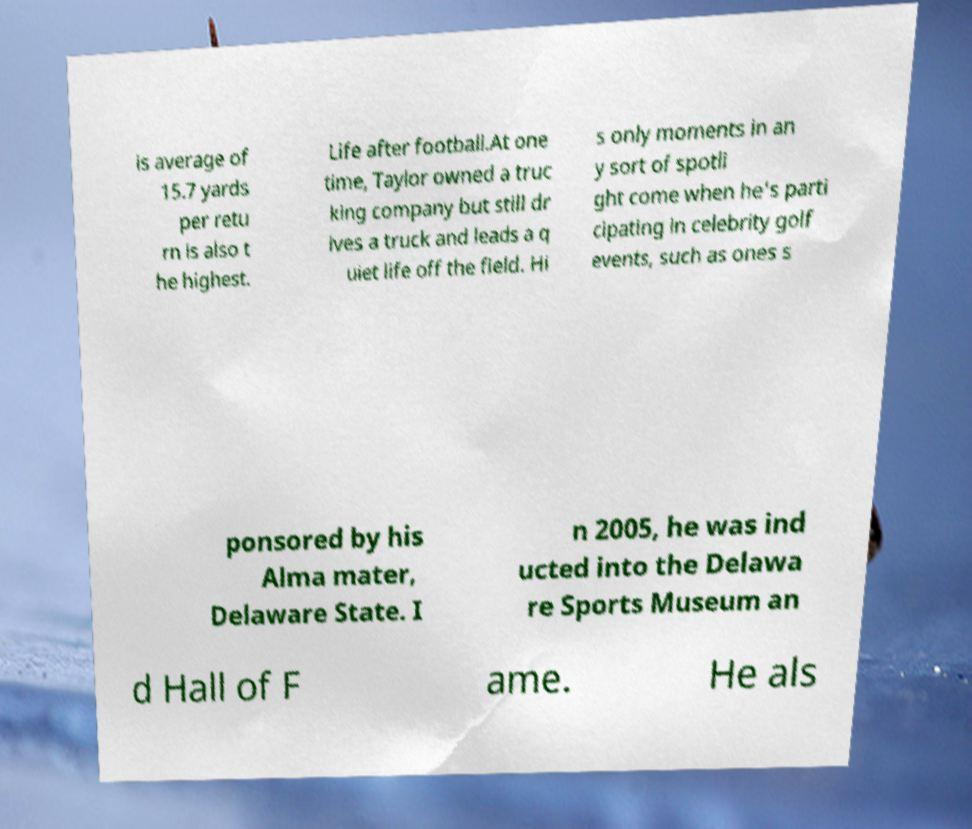Please read and relay the text visible in this image. What does it say? is average of 15.7 yards per retu rn is also t he highest. Life after football.At one time, Taylor owned a truc king company but still dr ives a truck and leads a q uiet life off the field. Hi s only moments in an y sort of spotli ght come when he's parti cipating in celebrity golf events, such as ones s ponsored by his Alma mater, Delaware State. I n 2005, he was ind ucted into the Delawa re Sports Museum an d Hall of F ame. He als 